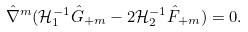Convert formula to latex. <formula><loc_0><loc_0><loc_500><loc_500>\hat { \nabla } ^ { m } ( \mathcal { H } _ { 1 } ^ { - 1 } \hat { G } _ { + m } - 2 \mathcal { H } _ { 2 } ^ { - 1 } \hat { F } _ { + m } ) = 0 .</formula> 